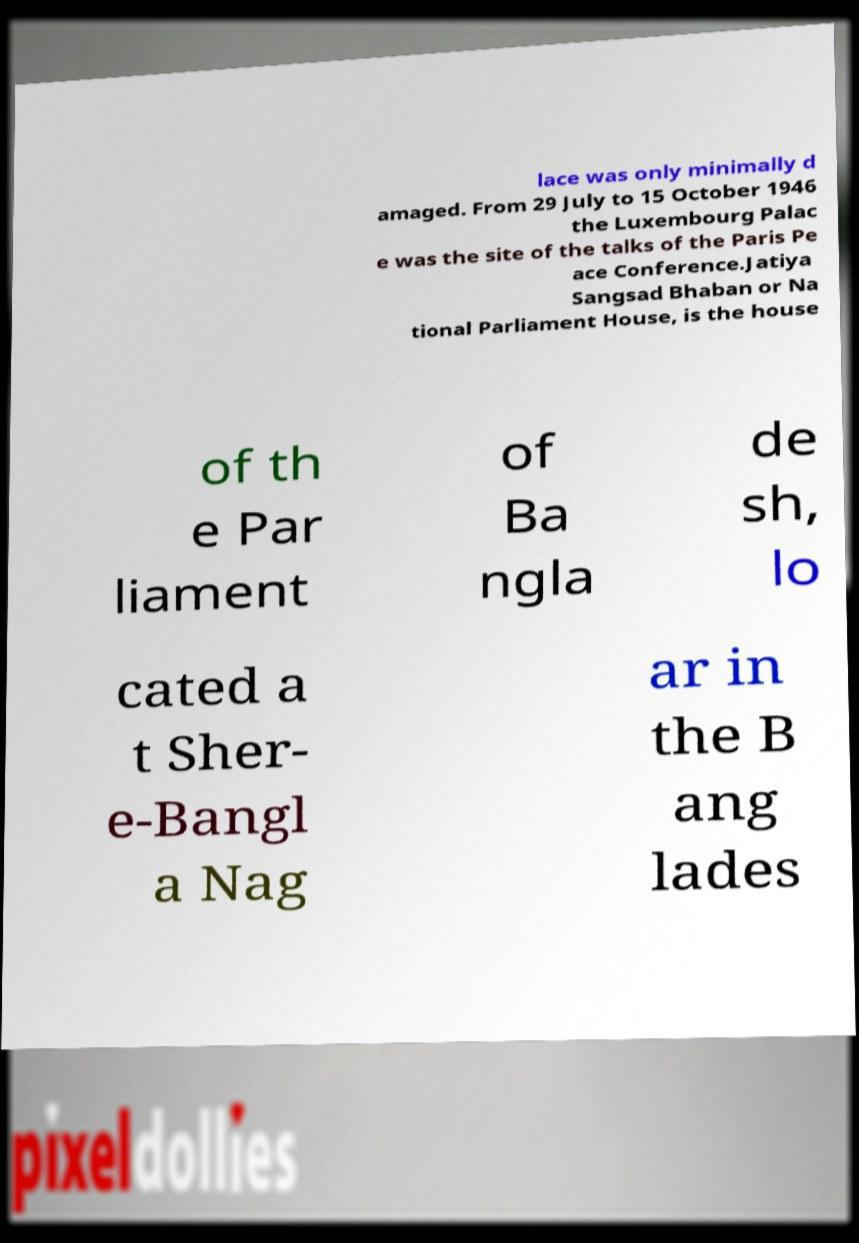Please identify and transcribe the text found in this image. lace was only minimally d amaged. From 29 July to 15 October 1946 the Luxembourg Palac e was the site of the talks of the Paris Pe ace Conference.Jatiya Sangsad Bhaban or Na tional Parliament House, is the house of th e Par liament of Ba ngla de sh, lo cated a t Sher- e-Bangl a Nag ar in the B ang lades 